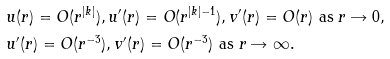<formula> <loc_0><loc_0><loc_500><loc_500>& u ( r ) = O ( r ^ { | k | } ) , u ^ { \prime } ( r ) = O ( r ^ { | k | - 1 } ) , v ^ { \prime } ( r ) = O ( r ) \text { as } r \rightarrow 0 , \\ & u ^ { \prime } ( r ) = O ( r ^ { - 3 } ) , v ^ { \prime } ( r ) = O ( r ^ { - 3 } ) \text { as } r \rightarrow \infty .</formula> 